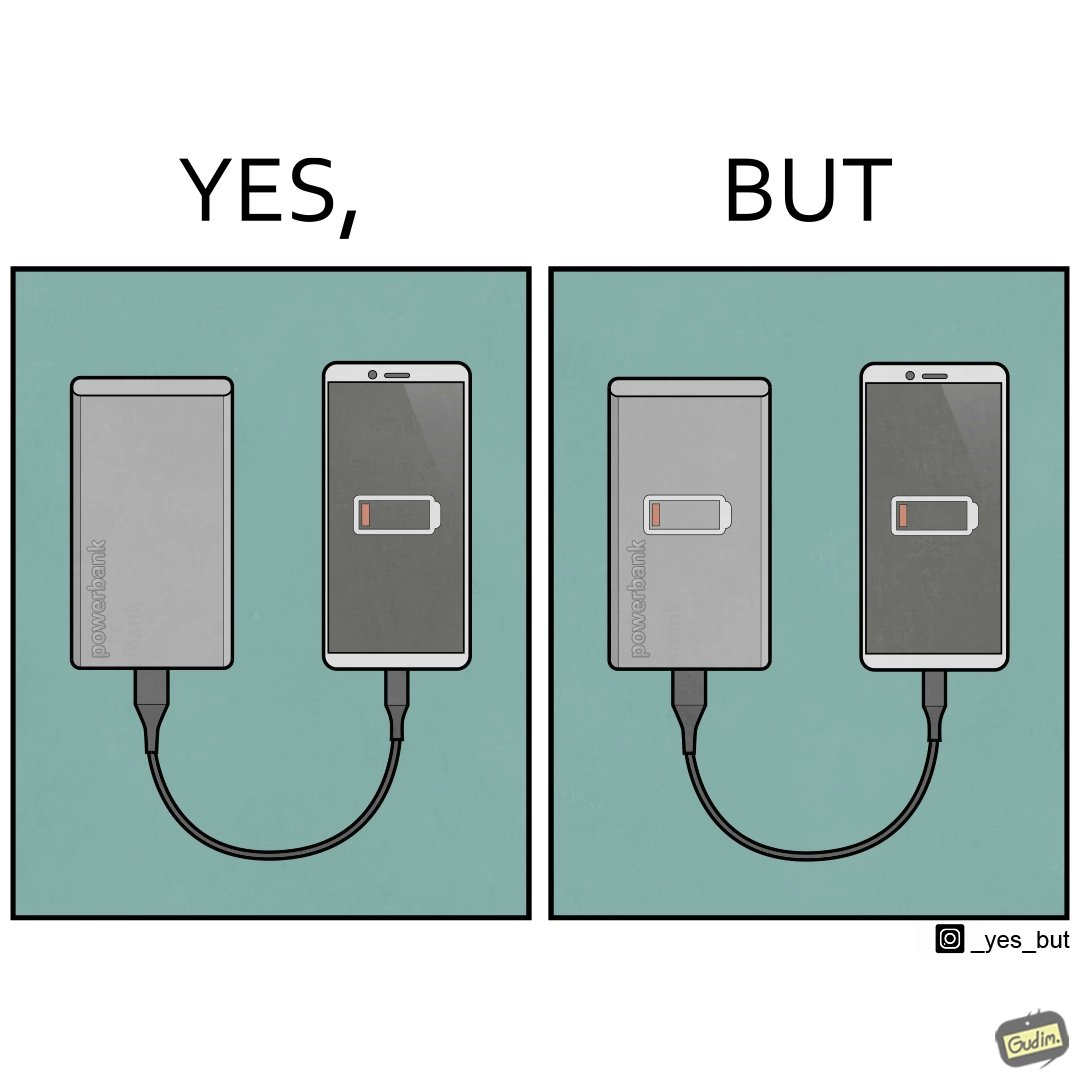Describe the content of this image. This image is funny because its an assumed expectation that  the dead phone will be rescued by the power bank, but here the power bank is also dead and of no use. 